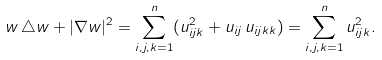Convert formula to latex. <formula><loc_0><loc_0><loc_500><loc_500>w \, \triangle w + | \nabla w | ^ { 2 } = \sum _ { i , j , k = 1 } ^ { n } ( u ^ { 2 } _ { i j k } + u _ { i j } \, u _ { i j k k } ) = \sum _ { i , j , k = 1 } ^ { n } u _ { i j k } ^ { 2 } .</formula> 